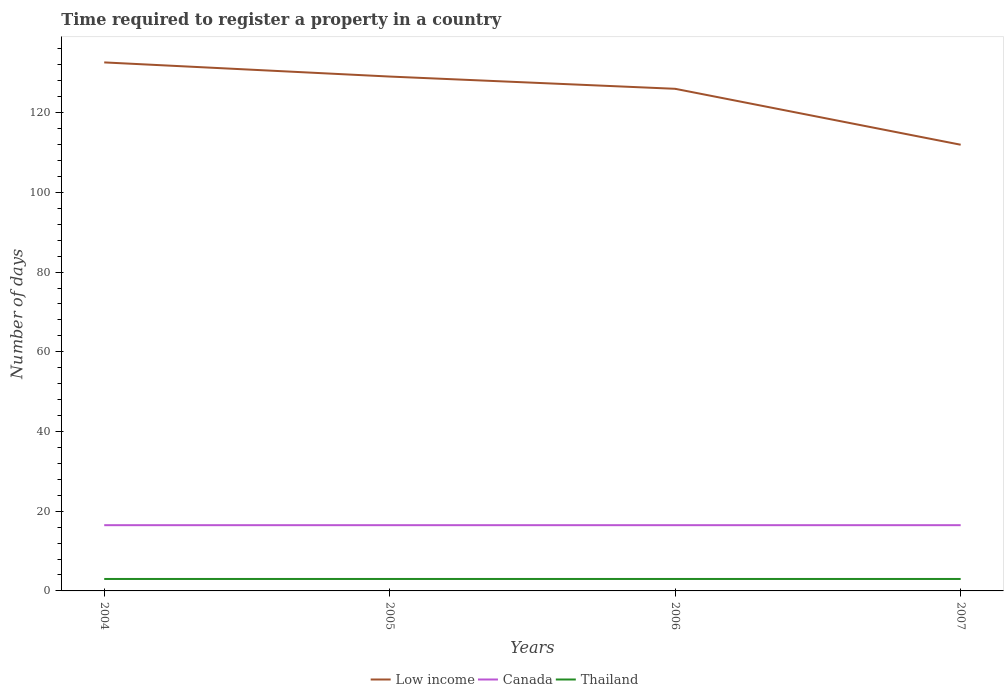Across all years, what is the maximum number of days required to register a property in Low income?
Your answer should be very brief. 111.96. In which year was the number of days required to register a property in Low income maximum?
Offer a very short reply. 2007. What is the difference between the highest and the lowest number of days required to register a property in Thailand?
Your answer should be compact. 0. How many years are there in the graph?
Offer a terse response. 4. Are the values on the major ticks of Y-axis written in scientific E-notation?
Provide a succinct answer. No. Does the graph contain any zero values?
Offer a very short reply. No. Does the graph contain grids?
Provide a succinct answer. No. What is the title of the graph?
Your answer should be compact. Time required to register a property in a country. What is the label or title of the Y-axis?
Make the answer very short. Number of days. What is the Number of days of Low income in 2004?
Offer a very short reply. 132.62. What is the Number of days in Canada in 2004?
Your answer should be very brief. 16.5. What is the Number of days of Thailand in 2004?
Your answer should be compact. 3. What is the Number of days in Low income in 2005?
Give a very brief answer. 129.07. What is the Number of days of Canada in 2005?
Your response must be concise. 16.5. What is the Number of days in Low income in 2006?
Make the answer very short. 126. What is the Number of days of Canada in 2006?
Keep it short and to the point. 16.5. What is the Number of days of Thailand in 2006?
Provide a short and direct response. 3. What is the Number of days in Low income in 2007?
Provide a succinct answer. 111.96. What is the Number of days of Canada in 2007?
Provide a short and direct response. 16.5. Across all years, what is the maximum Number of days of Low income?
Give a very brief answer. 132.62. Across all years, what is the maximum Number of days in Canada?
Make the answer very short. 16.5. Across all years, what is the maximum Number of days in Thailand?
Offer a very short reply. 3. Across all years, what is the minimum Number of days in Low income?
Your response must be concise. 111.96. Across all years, what is the minimum Number of days in Canada?
Provide a succinct answer. 16.5. What is the total Number of days of Low income in the graph?
Give a very brief answer. 499.66. What is the total Number of days of Canada in the graph?
Offer a very short reply. 66. What is the total Number of days in Thailand in the graph?
Provide a succinct answer. 12. What is the difference between the Number of days of Low income in 2004 and that in 2005?
Offer a very short reply. 3.55. What is the difference between the Number of days of Thailand in 2004 and that in 2005?
Offer a very short reply. 0. What is the difference between the Number of days of Low income in 2004 and that in 2006?
Your response must be concise. 6.62. What is the difference between the Number of days in Thailand in 2004 and that in 2006?
Give a very brief answer. 0. What is the difference between the Number of days in Low income in 2004 and that in 2007?
Your answer should be compact. 20.66. What is the difference between the Number of days of Thailand in 2004 and that in 2007?
Make the answer very short. 0. What is the difference between the Number of days of Low income in 2005 and that in 2006?
Keep it short and to the point. 3.07. What is the difference between the Number of days in Canada in 2005 and that in 2006?
Offer a very short reply. 0. What is the difference between the Number of days of Low income in 2005 and that in 2007?
Provide a succinct answer. 17.11. What is the difference between the Number of days in Thailand in 2005 and that in 2007?
Ensure brevity in your answer.  0. What is the difference between the Number of days of Low income in 2006 and that in 2007?
Ensure brevity in your answer.  14.04. What is the difference between the Number of days in Canada in 2006 and that in 2007?
Ensure brevity in your answer.  0. What is the difference between the Number of days in Thailand in 2006 and that in 2007?
Make the answer very short. 0. What is the difference between the Number of days of Low income in 2004 and the Number of days of Canada in 2005?
Provide a succinct answer. 116.12. What is the difference between the Number of days in Low income in 2004 and the Number of days in Thailand in 2005?
Offer a very short reply. 129.62. What is the difference between the Number of days in Low income in 2004 and the Number of days in Canada in 2006?
Make the answer very short. 116.12. What is the difference between the Number of days in Low income in 2004 and the Number of days in Thailand in 2006?
Your response must be concise. 129.62. What is the difference between the Number of days in Canada in 2004 and the Number of days in Thailand in 2006?
Offer a very short reply. 13.5. What is the difference between the Number of days of Low income in 2004 and the Number of days of Canada in 2007?
Offer a terse response. 116.12. What is the difference between the Number of days of Low income in 2004 and the Number of days of Thailand in 2007?
Your answer should be very brief. 129.62. What is the difference between the Number of days of Canada in 2004 and the Number of days of Thailand in 2007?
Provide a short and direct response. 13.5. What is the difference between the Number of days in Low income in 2005 and the Number of days in Canada in 2006?
Ensure brevity in your answer.  112.57. What is the difference between the Number of days in Low income in 2005 and the Number of days in Thailand in 2006?
Your response must be concise. 126.07. What is the difference between the Number of days in Canada in 2005 and the Number of days in Thailand in 2006?
Provide a short and direct response. 13.5. What is the difference between the Number of days in Low income in 2005 and the Number of days in Canada in 2007?
Offer a very short reply. 112.57. What is the difference between the Number of days of Low income in 2005 and the Number of days of Thailand in 2007?
Offer a terse response. 126.07. What is the difference between the Number of days of Low income in 2006 and the Number of days of Canada in 2007?
Your answer should be very brief. 109.5. What is the difference between the Number of days in Low income in 2006 and the Number of days in Thailand in 2007?
Give a very brief answer. 123. What is the average Number of days of Low income per year?
Your answer should be compact. 124.92. What is the average Number of days in Canada per year?
Provide a succinct answer. 16.5. In the year 2004, what is the difference between the Number of days in Low income and Number of days in Canada?
Keep it short and to the point. 116.12. In the year 2004, what is the difference between the Number of days of Low income and Number of days of Thailand?
Give a very brief answer. 129.62. In the year 2004, what is the difference between the Number of days in Canada and Number of days in Thailand?
Give a very brief answer. 13.5. In the year 2005, what is the difference between the Number of days in Low income and Number of days in Canada?
Ensure brevity in your answer.  112.57. In the year 2005, what is the difference between the Number of days of Low income and Number of days of Thailand?
Ensure brevity in your answer.  126.07. In the year 2005, what is the difference between the Number of days of Canada and Number of days of Thailand?
Ensure brevity in your answer.  13.5. In the year 2006, what is the difference between the Number of days in Low income and Number of days in Canada?
Keep it short and to the point. 109.5. In the year 2006, what is the difference between the Number of days in Low income and Number of days in Thailand?
Give a very brief answer. 123. In the year 2007, what is the difference between the Number of days in Low income and Number of days in Canada?
Provide a short and direct response. 95.46. In the year 2007, what is the difference between the Number of days of Low income and Number of days of Thailand?
Your answer should be compact. 108.96. What is the ratio of the Number of days of Low income in 2004 to that in 2005?
Ensure brevity in your answer.  1.03. What is the ratio of the Number of days of Low income in 2004 to that in 2006?
Your response must be concise. 1.05. What is the ratio of the Number of days of Thailand in 2004 to that in 2006?
Provide a succinct answer. 1. What is the ratio of the Number of days of Low income in 2004 to that in 2007?
Ensure brevity in your answer.  1.18. What is the ratio of the Number of days of Canada in 2004 to that in 2007?
Provide a short and direct response. 1. What is the ratio of the Number of days of Thailand in 2004 to that in 2007?
Make the answer very short. 1. What is the ratio of the Number of days of Low income in 2005 to that in 2006?
Provide a succinct answer. 1.02. What is the ratio of the Number of days in Canada in 2005 to that in 2006?
Provide a short and direct response. 1. What is the ratio of the Number of days in Thailand in 2005 to that in 2006?
Keep it short and to the point. 1. What is the ratio of the Number of days of Low income in 2005 to that in 2007?
Your answer should be compact. 1.15. What is the ratio of the Number of days of Canada in 2005 to that in 2007?
Your response must be concise. 1. What is the ratio of the Number of days of Low income in 2006 to that in 2007?
Offer a very short reply. 1.13. What is the ratio of the Number of days in Canada in 2006 to that in 2007?
Your response must be concise. 1. What is the ratio of the Number of days of Thailand in 2006 to that in 2007?
Your response must be concise. 1. What is the difference between the highest and the second highest Number of days in Low income?
Your response must be concise. 3.55. What is the difference between the highest and the second highest Number of days in Canada?
Your response must be concise. 0. What is the difference between the highest and the second highest Number of days of Thailand?
Provide a succinct answer. 0. What is the difference between the highest and the lowest Number of days in Low income?
Your response must be concise. 20.66. 